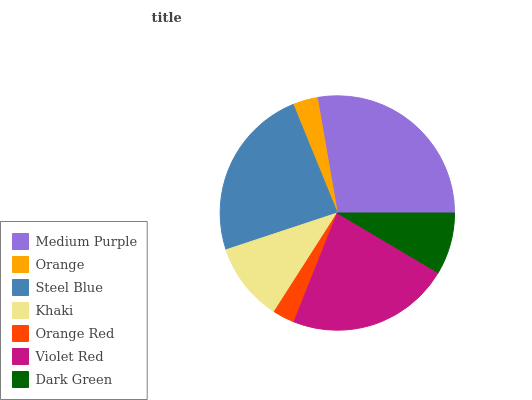Is Orange Red the minimum?
Answer yes or no. Yes. Is Medium Purple the maximum?
Answer yes or no. Yes. Is Orange the minimum?
Answer yes or no. No. Is Orange the maximum?
Answer yes or no. No. Is Medium Purple greater than Orange?
Answer yes or no. Yes. Is Orange less than Medium Purple?
Answer yes or no. Yes. Is Orange greater than Medium Purple?
Answer yes or no. No. Is Medium Purple less than Orange?
Answer yes or no. No. Is Khaki the high median?
Answer yes or no. Yes. Is Khaki the low median?
Answer yes or no. Yes. Is Orange Red the high median?
Answer yes or no. No. Is Medium Purple the low median?
Answer yes or no. No. 